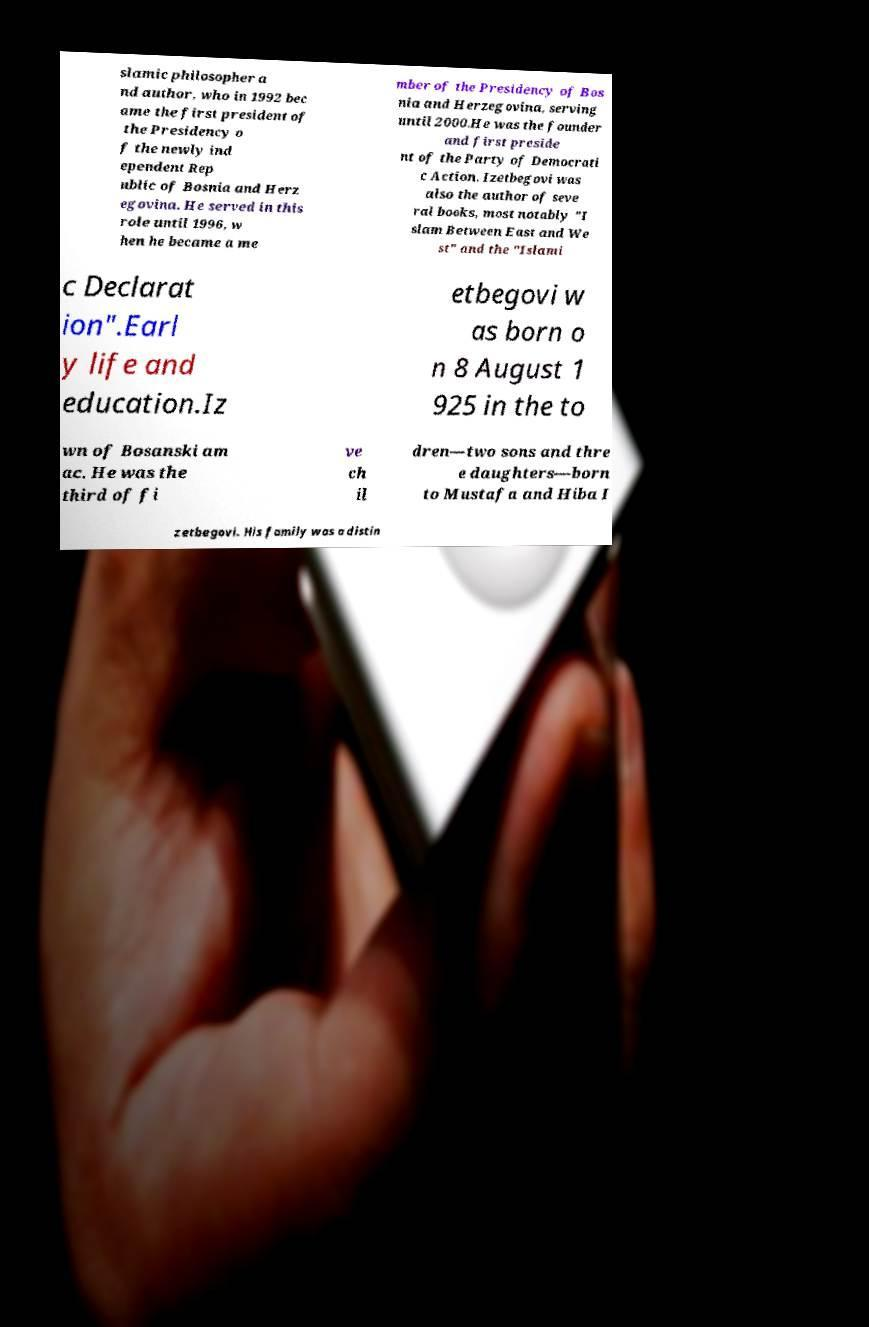Could you assist in decoding the text presented in this image and type it out clearly? slamic philosopher a nd author, who in 1992 bec ame the first president of the Presidency o f the newly ind ependent Rep ublic of Bosnia and Herz egovina. He served in this role until 1996, w hen he became a me mber of the Presidency of Bos nia and Herzegovina, serving until 2000.He was the founder and first preside nt of the Party of Democrati c Action. Izetbegovi was also the author of seve ral books, most notably "I slam Between East and We st" and the "Islami c Declarat ion".Earl y life and education.Iz etbegovi w as born o n 8 August 1 925 in the to wn of Bosanski am ac. He was the third of fi ve ch il dren—two sons and thre e daughters—born to Mustafa and Hiba I zetbegovi. His family was a distin 